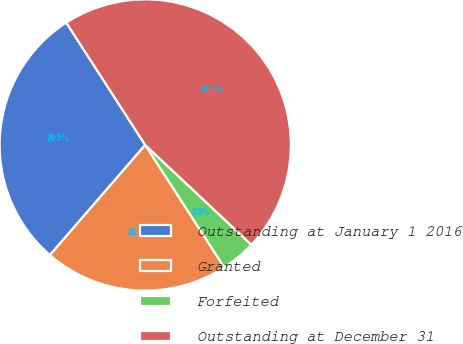<chart> <loc_0><loc_0><loc_500><loc_500><pie_chart><fcel>Outstanding at January 1 2016<fcel>Granted<fcel>Forfeited<fcel>Outstanding at December 31<nl><fcel>29.52%<fcel>20.48%<fcel>3.87%<fcel>46.13%<nl></chart> 